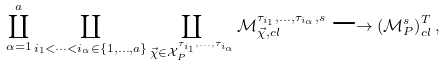<formula> <loc_0><loc_0><loc_500><loc_500>\coprod _ { \alpha = 1 } ^ { a } \coprod _ { i _ { 1 } < \cdots < i _ { \alpha } \in \{ 1 , \dots , a \} } \coprod _ { \vec { \chi } \in \mathcal { X } _ { P } ^ { \tau _ { i _ { 1 } } , \dots , \tau _ { i _ { \alpha } } } } \mathcal { M } _ { \vec { \chi } , c l } ^ { \tau _ { i _ { 1 } } , \dots , \tau _ { i _ { \alpha } } , s } \longrightarrow \left ( \mathcal { M } _ { P } ^ { s } \right ) _ { c l } ^ { T } ,</formula> 